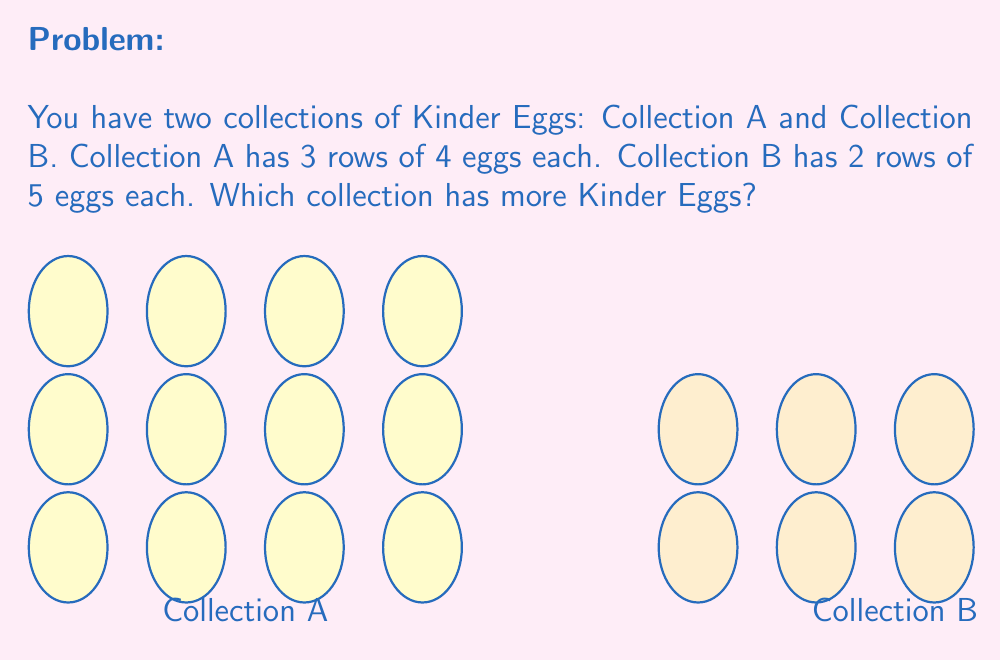Solve this math problem. To compare the sizes of the collections, we need to calculate the total number of Kinder Eggs in each:

1. For Collection A:
   - There are 3 rows with 4 eggs in each row
   - Total eggs in A = $3 \times 4 = 12$

2. For Collection B:
   - There are 2 rows with 5 eggs in each row
   - Total eggs in B = $2 \times 5 = 10$

3. Compare the totals:
   $12 > 10$

Therefore, Collection A has more Kinder Eggs than Collection B.
Answer: Collection A 